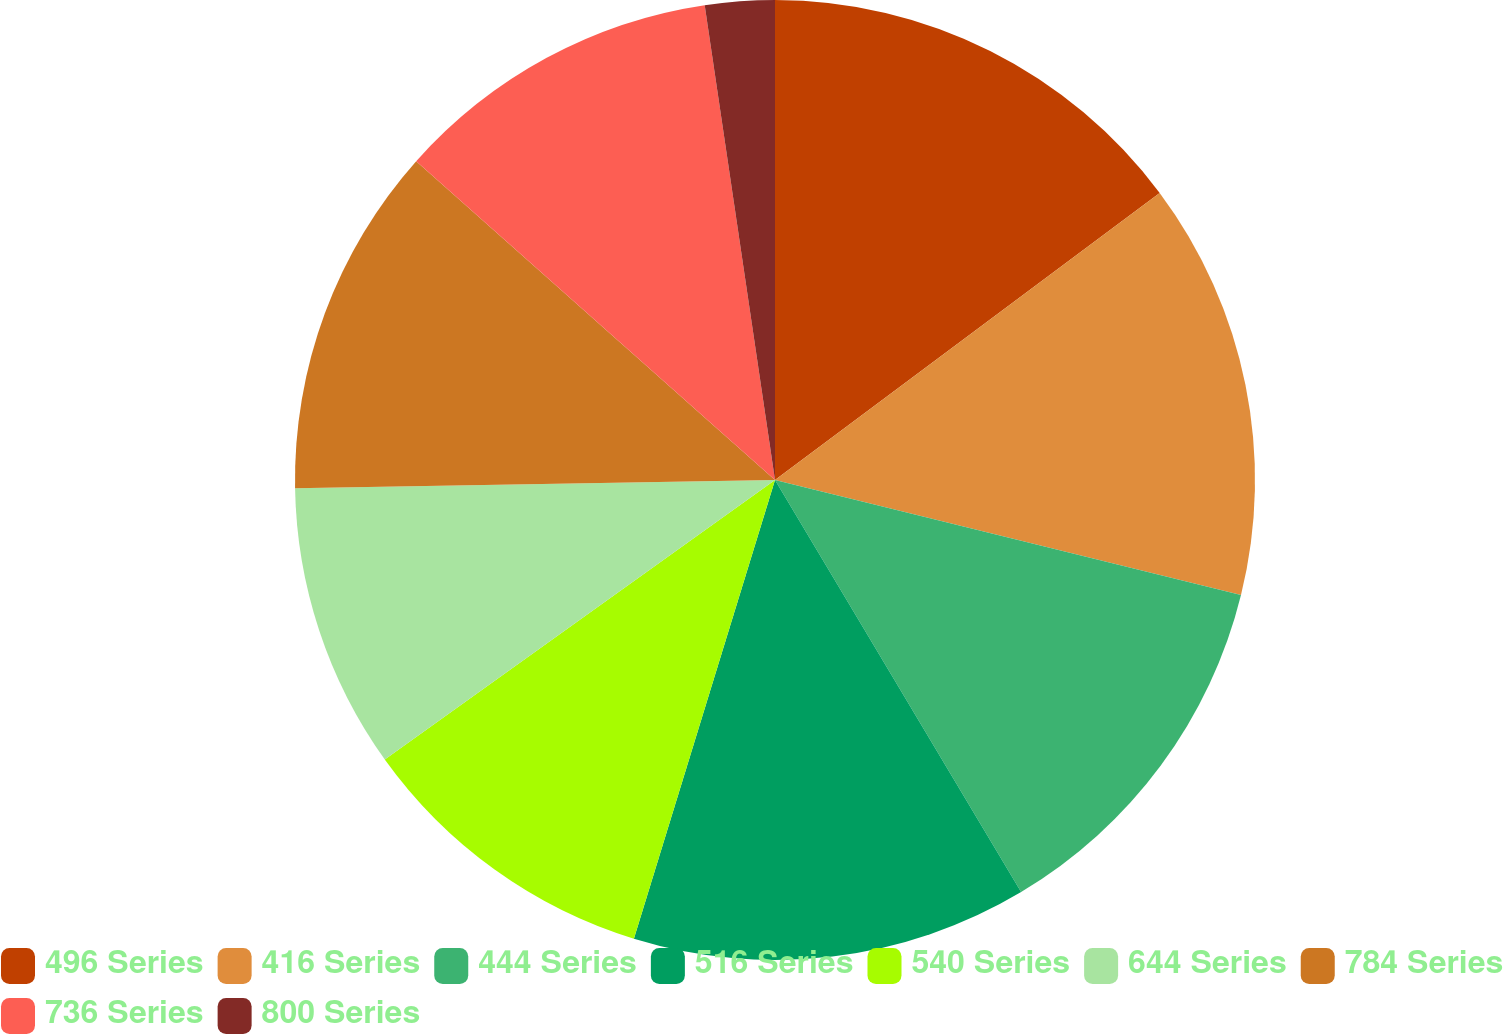Convert chart to OTSL. <chart><loc_0><loc_0><loc_500><loc_500><pie_chart><fcel>496 Series<fcel>416 Series<fcel>444 Series<fcel>516 Series<fcel>540 Series<fcel>644 Series<fcel>784 Series<fcel>736 Series<fcel>800 Series<nl><fcel>14.8%<fcel>14.06%<fcel>12.58%<fcel>13.32%<fcel>10.36%<fcel>9.62%<fcel>11.84%<fcel>11.1%<fcel>2.34%<nl></chart> 